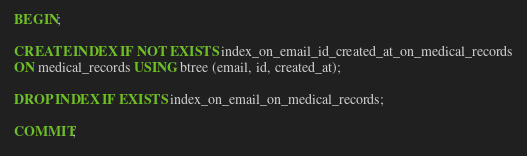<code> <loc_0><loc_0><loc_500><loc_500><_SQL_>BEGIN;

CREATE INDEX IF NOT EXISTS index_on_email_id_created_at_on_medical_records
ON medical_records USING btree (email, id, created_at);

DROP INDEX IF EXISTS index_on_email_on_medical_records;

COMMIT;</code> 